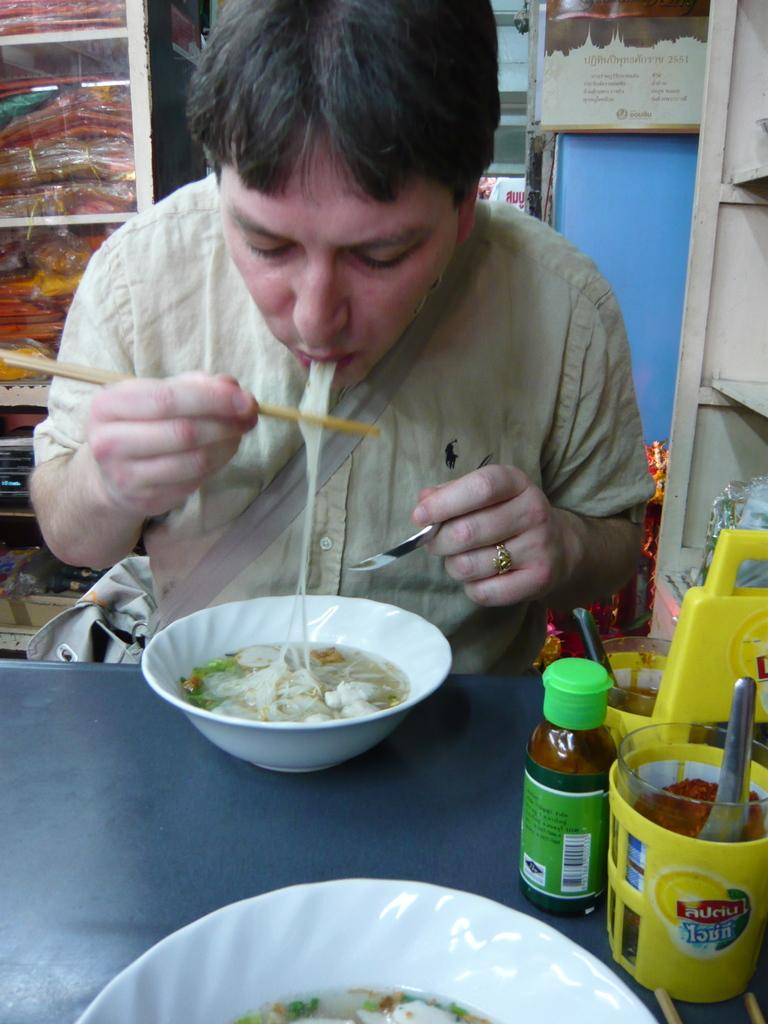<image>
Offer a succinct explanation of the picture presented. A yellow container on the table has the text "auciu" on it. 